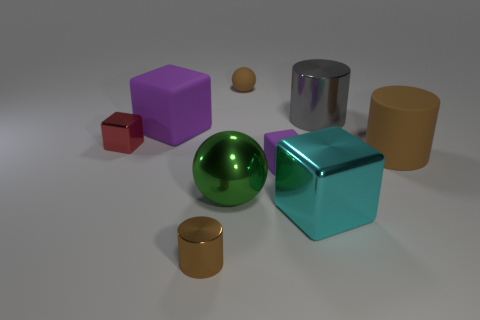Add 1 cyan blocks. How many objects exist? 10 Subtract all balls. How many objects are left? 7 Subtract all small objects. Subtract all small blocks. How many objects are left? 3 Add 6 big balls. How many big balls are left? 7 Add 4 large cyan shiny objects. How many large cyan shiny objects exist? 5 Subtract 1 gray cylinders. How many objects are left? 8 